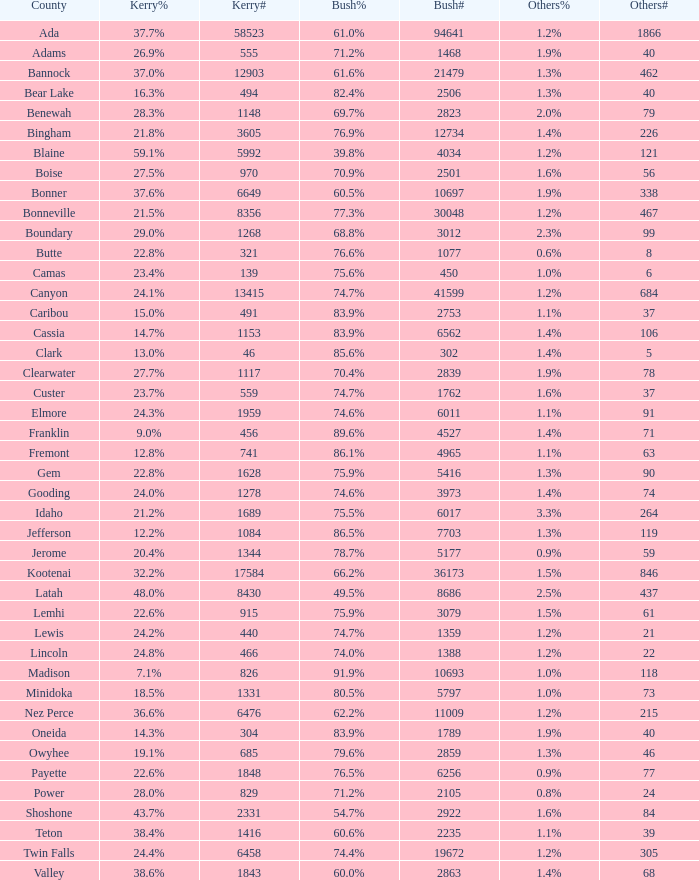In the county where bush secured 6 1.0. 